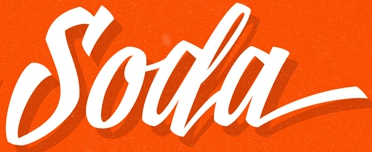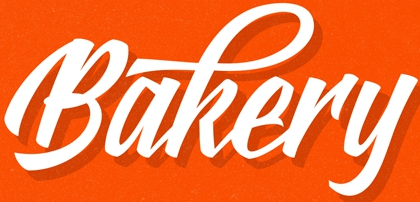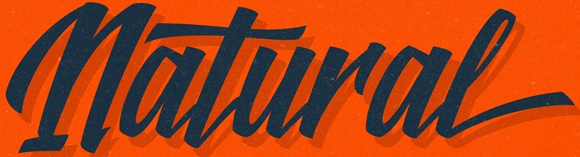What words can you see in these images in sequence, separated by a semicolon? Soda; Bakery; Natural 